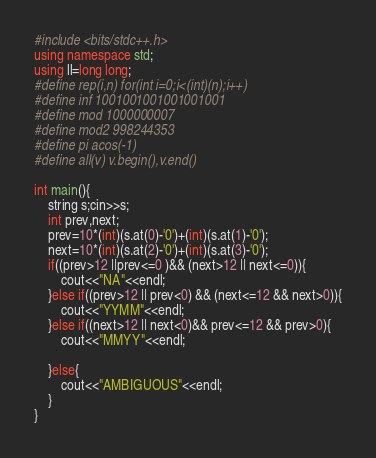Convert code to text. <code><loc_0><loc_0><loc_500><loc_500><_C++_>#include <bits/stdc++.h>
using namespace std;
using ll=long long;
#define rep(i,n) for(int i=0;i<(int)(n);i++)
#define inf 1001001001001001001
#define mod 1000000007
#define mod2 998244353
#define pi acos(-1)
#define all(v) v.begin(),v.end()

int main(){
    string s;cin>>s;
    int prev,next;
    prev=10*(int)(s.at(0)-'0')+(int)(s.at(1)-'0');
    next=10*(int)(s.at(2)-'0')+(int)(s.at(3)-'0');
    if((prev>12 ||prev<=0 )&& (next>12 || next<=0)){
        cout<<"NA"<<endl;
    }else if((prev>12 || prev<0) && (next<=12 && next>0)){
        cout<<"YYMM"<<endl;
    }else if((next>12 || next<0)&& prev<=12 && prev>0){
        cout<<"MMYY"<<endl;

    }else{
        cout<<"AMBIGUOUS"<<endl;
    }
}
</code> 